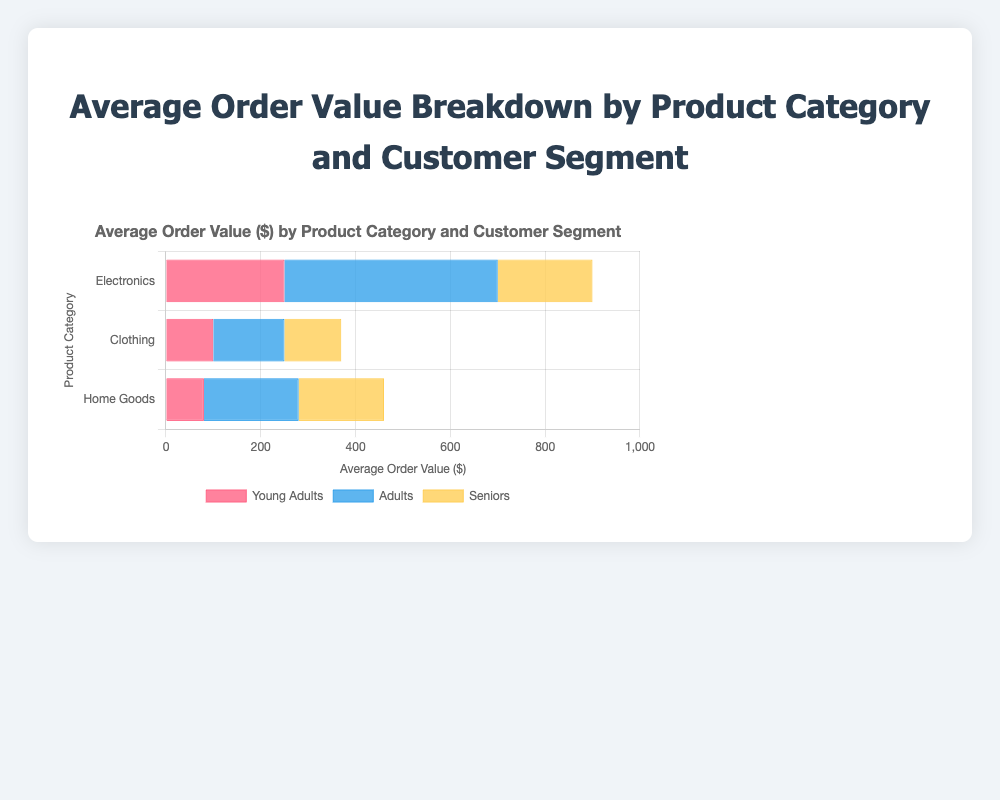What is the Average Order Value for "Electronics" among "Adults"? The Average Order Value for the "Electronics" product category among the "Adults" customer segment is shown by the length of the red bar representing "Adults" in the "Electronics" category. The value is labeled as 450.
Answer: 450 Which product category has the highest Average Order Value for "Seniors"? To determine the highest Average Order Value for "Seniors," compare the yellow bar lengths across the different product categories. The highest yellow bar is in the "Electronics" category with a value of 200.
Answer: Electronics Compare the Average Order Value between "Young Adults" and "Adults" within the "Clothing" category. Which segment is higher, and by how much? The Average Order Value for "Young Adults" in "Clothing" is 100, and for "Adults," it is 150. Subtracting these values (150 - 100) gives a difference of 50, indicating "Adults" have a higher value by 50.
Answer: Adults, 50 What is the total Average Order Value for "Home Goods" across all customer segments? Summing up the Average Order Values for "Home Goods," we have: Young Adults: 80, Adults: 200, Seniors: 180. Adding these gives 80 + 200 + 180 = 460.
Answer: 460 Which customer segment contributed the most to the Average Order Value in "Electronics," and what is the value? By observing the bar lengths for "Electronics," the "Adults" segment has the longest blue bar among the three customer segments with an Average Order Value of 450, the highest value.
Answer: Adults, 450 How does the Average Order Value for "Seniors" in "Clothing" compare to that in "Home Goods"? The Average Order Value for "Seniors" in "Clothing" is 120, while in "Home Goods," it is 180. Comparing these values, 180 - 120 = 60, thus "Home Goods" has a higher value by 60.
Answer: Home Goods has 60 higher Which customer segment has the lowest Average Order Value for "Home Goods" and what is the value? Identifying the shortest bar in the "Home Goods" category, the "Young Adults" segment has the lowest Average Order Value with the length representing a value of 80.
Answer: Young Adults, 80 What is the average of the Average Order Values in the "Clothing" category across all segments? The Average Order Values for "Clothing" are 100 (Young Adults), 150 (Adults), and 120 (Seniors). The sum is 100 + 150 + 120 = 370. Dividing by the number of segments (3) gives 370 / 3 ≈ 123.33.
Answer: 123.33 